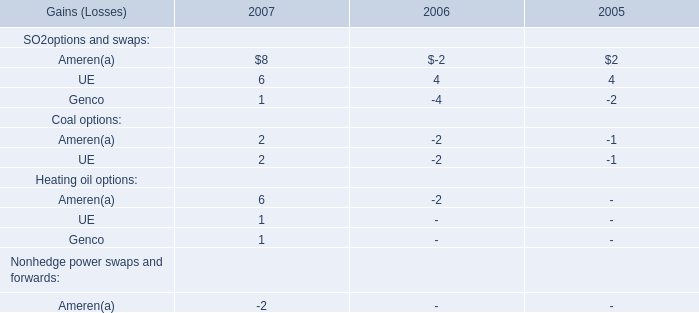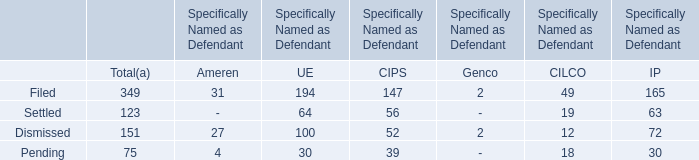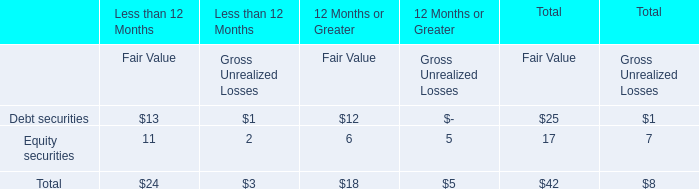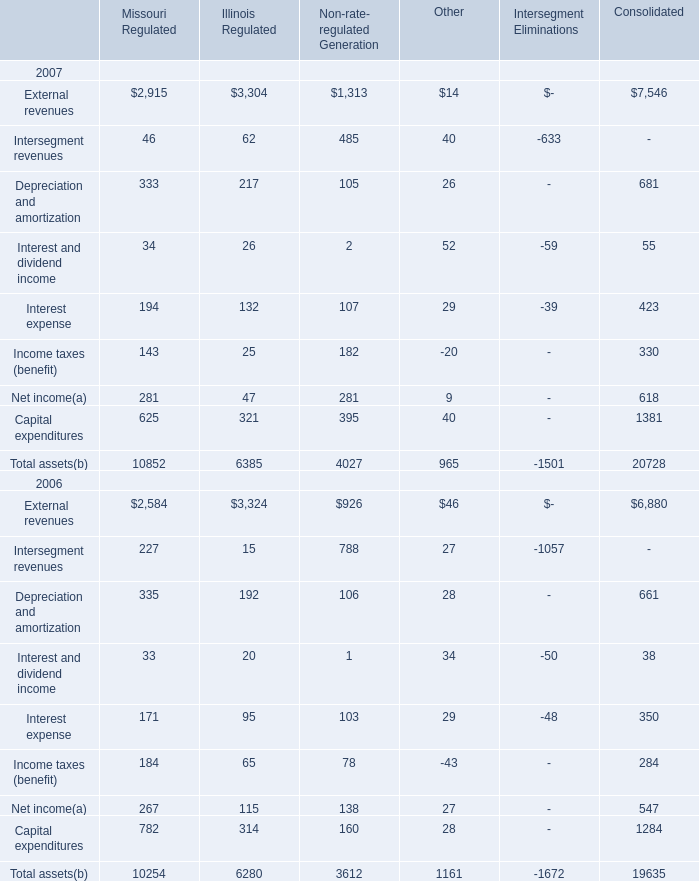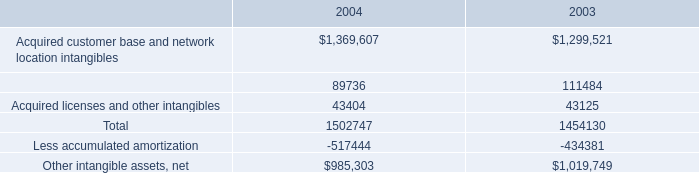What is the total amount of Capital expenditures of Consolidated, Acquired licenses and other intangibles of 2003, and Total assets 2006 of Intersegment Eliminations ? 
Computations: ((1381.0 + 43125.0) + 1672.0)
Answer: 46178.0. 